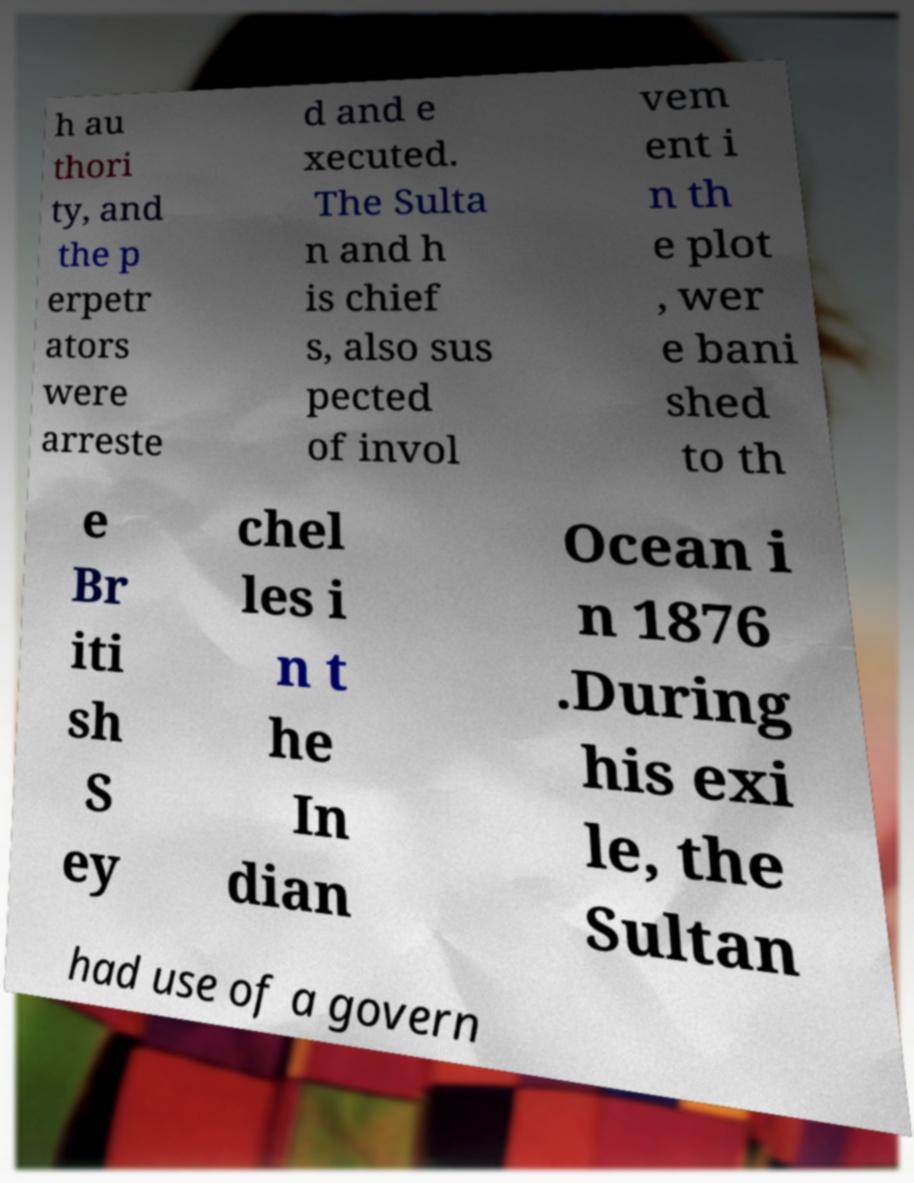Could you assist in decoding the text presented in this image and type it out clearly? h au thori ty, and the p erpetr ators were arreste d and e xecuted. The Sulta n and h is chief s, also sus pected of invol vem ent i n th e plot , wer e bani shed to th e Br iti sh S ey chel les i n t he In dian Ocean i n 1876 .During his exi le, the Sultan had use of a govern 